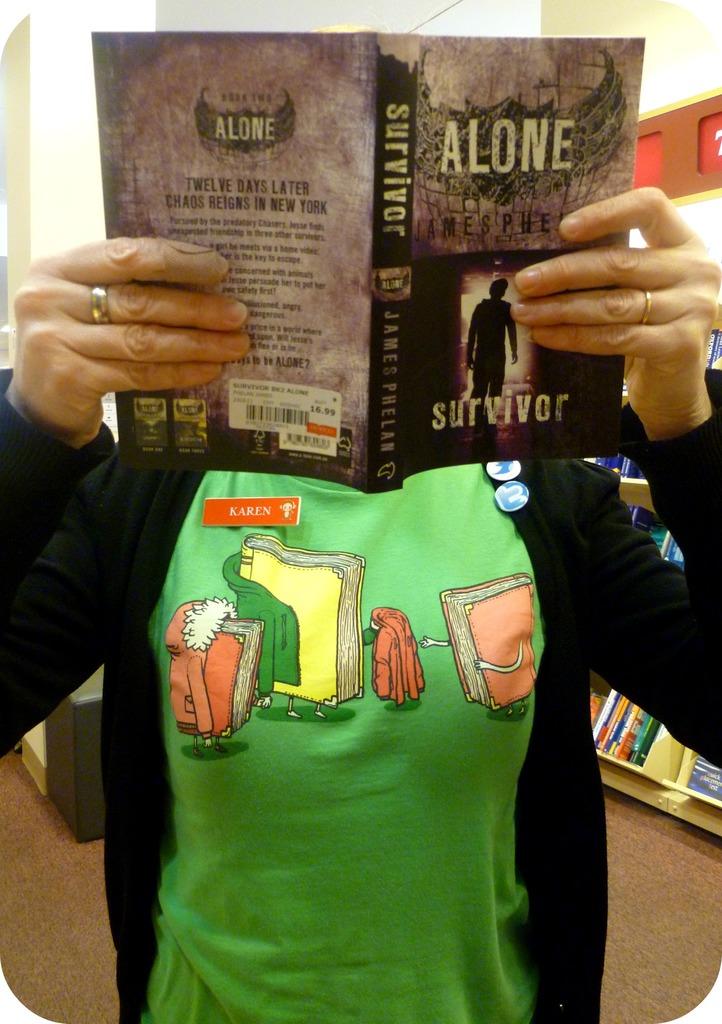What is the title of the book?
Ensure brevity in your answer.  Alone. What is the authors name of this book?
Provide a succinct answer. James phelan. 